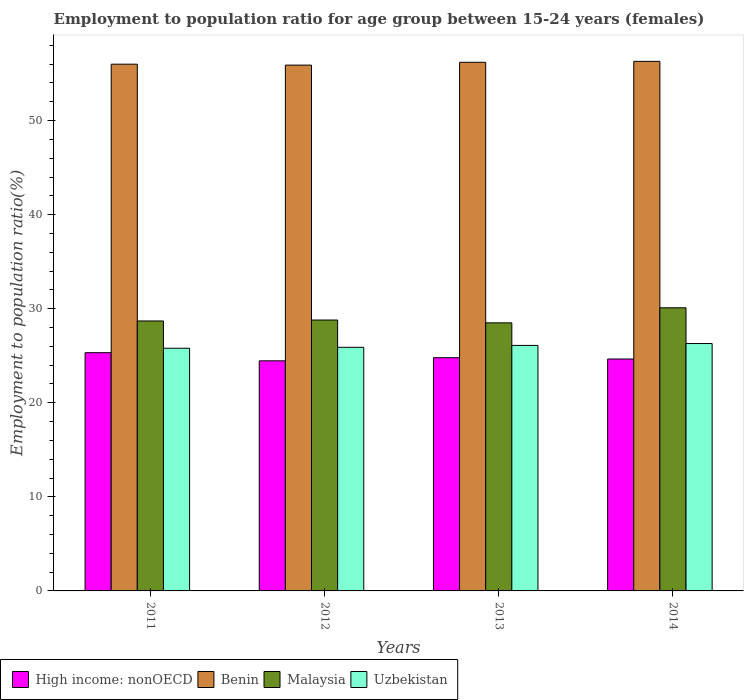How many groups of bars are there?
Your response must be concise. 4. Are the number of bars on each tick of the X-axis equal?
Offer a very short reply. Yes. How many bars are there on the 3rd tick from the right?
Your answer should be very brief. 4. In how many cases, is the number of bars for a given year not equal to the number of legend labels?
Your response must be concise. 0. What is the employment to population ratio in Benin in 2012?
Provide a succinct answer. 55.9. Across all years, what is the maximum employment to population ratio in Malaysia?
Provide a short and direct response. 30.1. Across all years, what is the minimum employment to population ratio in Benin?
Provide a short and direct response. 55.9. In which year was the employment to population ratio in Malaysia maximum?
Your answer should be very brief. 2014. In which year was the employment to population ratio in Benin minimum?
Provide a succinct answer. 2012. What is the total employment to population ratio in High income: nonOECD in the graph?
Your answer should be compact. 99.24. What is the difference between the employment to population ratio in Benin in 2013 and that in 2014?
Your response must be concise. -0.1. What is the difference between the employment to population ratio in Malaysia in 2014 and the employment to population ratio in Benin in 2013?
Provide a short and direct response. -26.1. What is the average employment to population ratio in High income: nonOECD per year?
Make the answer very short. 24.81. In the year 2013, what is the difference between the employment to population ratio in Uzbekistan and employment to population ratio in Benin?
Ensure brevity in your answer.  -30.1. What is the ratio of the employment to population ratio in High income: nonOECD in 2012 to that in 2014?
Ensure brevity in your answer.  0.99. What is the difference between the highest and the second highest employment to population ratio in Benin?
Ensure brevity in your answer.  0.1. What is the difference between the highest and the lowest employment to population ratio in Benin?
Provide a short and direct response. 0.4. In how many years, is the employment to population ratio in High income: nonOECD greater than the average employment to population ratio in High income: nonOECD taken over all years?
Your response must be concise. 1. Is it the case that in every year, the sum of the employment to population ratio in Uzbekistan and employment to population ratio in High income: nonOECD is greater than the sum of employment to population ratio in Benin and employment to population ratio in Malaysia?
Give a very brief answer. No. What does the 4th bar from the left in 2012 represents?
Keep it short and to the point. Uzbekistan. What does the 3rd bar from the right in 2013 represents?
Provide a short and direct response. Benin. Is it the case that in every year, the sum of the employment to population ratio in Benin and employment to population ratio in High income: nonOECD is greater than the employment to population ratio in Uzbekistan?
Provide a short and direct response. Yes. How many bars are there?
Ensure brevity in your answer.  16. How many years are there in the graph?
Your response must be concise. 4. Are the values on the major ticks of Y-axis written in scientific E-notation?
Give a very brief answer. No. Does the graph contain any zero values?
Provide a succinct answer. No. Does the graph contain grids?
Your answer should be compact. No. Where does the legend appear in the graph?
Your answer should be compact. Bottom left. How many legend labels are there?
Give a very brief answer. 4. What is the title of the graph?
Offer a very short reply. Employment to population ratio for age group between 15-24 years (females). Does "Benin" appear as one of the legend labels in the graph?
Keep it short and to the point. Yes. What is the label or title of the X-axis?
Give a very brief answer. Years. What is the label or title of the Y-axis?
Provide a succinct answer. Employment to population ratio(%). What is the Employment to population ratio(%) in High income: nonOECD in 2011?
Your answer should be compact. 25.33. What is the Employment to population ratio(%) in Malaysia in 2011?
Offer a terse response. 28.7. What is the Employment to population ratio(%) in Uzbekistan in 2011?
Your response must be concise. 25.8. What is the Employment to population ratio(%) of High income: nonOECD in 2012?
Your answer should be compact. 24.46. What is the Employment to population ratio(%) of Benin in 2012?
Provide a short and direct response. 55.9. What is the Employment to population ratio(%) in Malaysia in 2012?
Your answer should be very brief. 28.8. What is the Employment to population ratio(%) in Uzbekistan in 2012?
Provide a short and direct response. 25.9. What is the Employment to population ratio(%) of High income: nonOECD in 2013?
Provide a short and direct response. 24.79. What is the Employment to population ratio(%) in Benin in 2013?
Offer a very short reply. 56.2. What is the Employment to population ratio(%) in Uzbekistan in 2013?
Offer a very short reply. 26.1. What is the Employment to population ratio(%) in High income: nonOECD in 2014?
Your response must be concise. 24.66. What is the Employment to population ratio(%) in Benin in 2014?
Provide a short and direct response. 56.3. What is the Employment to population ratio(%) of Malaysia in 2014?
Give a very brief answer. 30.1. What is the Employment to population ratio(%) of Uzbekistan in 2014?
Offer a terse response. 26.3. Across all years, what is the maximum Employment to population ratio(%) of High income: nonOECD?
Offer a terse response. 25.33. Across all years, what is the maximum Employment to population ratio(%) in Benin?
Your response must be concise. 56.3. Across all years, what is the maximum Employment to population ratio(%) in Malaysia?
Offer a terse response. 30.1. Across all years, what is the maximum Employment to population ratio(%) of Uzbekistan?
Offer a very short reply. 26.3. Across all years, what is the minimum Employment to population ratio(%) of High income: nonOECD?
Your response must be concise. 24.46. Across all years, what is the minimum Employment to population ratio(%) in Benin?
Your answer should be very brief. 55.9. Across all years, what is the minimum Employment to population ratio(%) of Malaysia?
Provide a short and direct response. 28.5. Across all years, what is the minimum Employment to population ratio(%) of Uzbekistan?
Provide a succinct answer. 25.8. What is the total Employment to population ratio(%) of High income: nonOECD in the graph?
Make the answer very short. 99.24. What is the total Employment to population ratio(%) of Benin in the graph?
Your response must be concise. 224.4. What is the total Employment to population ratio(%) of Malaysia in the graph?
Keep it short and to the point. 116.1. What is the total Employment to population ratio(%) of Uzbekistan in the graph?
Provide a short and direct response. 104.1. What is the difference between the Employment to population ratio(%) of High income: nonOECD in 2011 and that in 2012?
Keep it short and to the point. 0.86. What is the difference between the Employment to population ratio(%) of Benin in 2011 and that in 2012?
Your response must be concise. 0.1. What is the difference between the Employment to population ratio(%) in Uzbekistan in 2011 and that in 2012?
Your response must be concise. -0.1. What is the difference between the Employment to population ratio(%) in High income: nonOECD in 2011 and that in 2013?
Give a very brief answer. 0.53. What is the difference between the Employment to population ratio(%) of High income: nonOECD in 2011 and that in 2014?
Offer a terse response. 0.67. What is the difference between the Employment to population ratio(%) in Malaysia in 2011 and that in 2014?
Ensure brevity in your answer.  -1.4. What is the difference between the Employment to population ratio(%) of Uzbekistan in 2011 and that in 2014?
Provide a short and direct response. -0.5. What is the difference between the Employment to population ratio(%) of High income: nonOECD in 2012 and that in 2013?
Keep it short and to the point. -0.33. What is the difference between the Employment to population ratio(%) of Benin in 2012 and that in 2013?
Your answer should be compact. -0.3. What is the difference between the Employment to population ratio(%) of Malaysia in 2012 and that in 2013?
Your response must be concise. 0.3. What is the difference between the Employment to population ratio(%) of Uzbekistan in 2012 and that in 2013?
Keep it short and to the point. -0.2. What is the difference between the Employment to population ratio(%) in High income: nonOECD in 2012 and that in 2014?
Give a very brief answer. -0.19. What is the difference between the Employment to population ratio(%) of Benin in 2012 and that in 2014?
Offer a terse response. -0.4. What is the difference between the Employment to population ratio(%) of Malaysia in 2012 and that in 2014?
Your response must be concise. -1.3. What is the difference between the Employment to population ratio(%) in High income: nonOECD in 2013 and that in 2014?
Offer a very short reply. 0.14. What is the difference between the Employment to population ratio(%) in Benin in 2013 and that in 2014?
Provide a succinct answer. -0.1. What is the difference between the Employment to population ratio(%) of Malaysia in 2013 and that in 2014?
Your answer should be compact. -1.6. What is the difference between the Employment to population ratio(%) in High income: nonOECD in 2011 and the Employment to population ratio(%) in Benin in 2012?
Give a very brief answer. -30.57. What is the difference between the Employment to population ratio(%) of High income: nonOECD in 2011 and the Employment to population ratio(%) of Malaysia in 2012?
Provide a succinct answer. -3.47. What is the difference between the Employment to population ratio(%) in High income: nonOECD in 2011 and the Employment to population ratio(%) in Uzbekistan in 2012?
Ensure brevity in your answer.  -0.57. What is the difference between the Employment to population ratio(%) in Benin in 2011 and the Employment to population ratio(%) in Malaysia in 2012?
Your answer should be compact. 27.2. What is the difference between the Employment to population ratio(%) in Benin in 2011 and the Employment to population ratio(%) in Uzbekistan in 2012?
Keep it short and to the point. 30.1. What is the difference between the Employment to population ratio(%) in Malaysia in 2011 and the Employment to population ratio(%) in Uzbekistan in 2012?
Offer a very short reply. 2.8. What is the difference between the Employment to population ratio(%) in High income: nonOECD in 2011 and the Employment to population ratio(%) in Benin in 2013?
Offer a very short reply. -30.87. What is the difference between the Employment to population ratio(%) in High income: nonOECD in 2011 and the Employment to population ratio(%) in Malaysia in 2013?
Keep it short and to the point. -3.17. What is the difference between the Employment to population ratio(%) of High income: nonOECD in 2011 and the Employment to population ratio(%) of Uzbekistan in 2013?
Keep it short and to the point. -0.77. What is the difference between the Employment to population ratio(%) in Benin in 2011 and the Employment to population ratio(%) in Malaysia in 2013?
Provide a succinct answer. 27.5. What is the difference between the Employment to population ratio(%) in Benin in 2011 and the Employment to population ratio(%) in Uzbekistan in 2013?
Give a very brief answer. 29.9. What is the difference between the Employment to population ratio(%) in Malaysia in 2011 and the Employment to population ratio(%) in Uzbekistan in 2013?
Your answer should be very brief. 2.6. What is the difference between the Employment to population ratio(%) in High income: nonOECD in 2011 and the Employment to population ratio(%) in Benin in 2014?
Offer a very short reply. -30.97. What is the difference between the Employment to population ratio(%) in High income: nonOECD in 2011 and the Employment to population ratio(%) in Malaysia in 2014?
Provide a short and direct response. -4.77. What is the difference between the Employment to population ratio(%) in High income: nonOECD in 2011 and the Employment to population ratio(%) in Uzbekistan in 2014?
Offer a very short reply. -0.97. What is the difference between the Employment to population ratio(%) in Benin in 2011 and the Employment to population ratio(%) in Malaysia in 2014?
Offer a terse response. 25.9. What is the difference between the Employment to population ratio(%) in Benin in 2011 and the Employment to population ratio(%) in Uzbekistan in 2014?
Offer a very short reply. 29.7. What is the difference between the Employment to population ratio(%) in Malaysia in 2011 and the Employment to population ratio(%) in Uzbekistan in 2014?
Offer a terse response. 2.4. What is the difference between the Employment to population ratio(%) in High income: nonOECD in 2012 and the Employment to population ratio(%) in Benin in 2013?
Your response must be concise. -31.74. What is the difference between the Employment to population ratio(%) of High income: nonOECD in 2012 and the Employment to population ratio(%) of Malaysia in 2013?
Offer a terse response. -4.04. What is the difference between the Employment to population ratio(%) of High income: nonOECD in 2012 and the Employment to population ratio(%) of Uzbekistan in 2013?
Your answer should be compact. -1.64. What is the difference between the Employment to population ratio(%) of Benin in 2012 and the Employment to population ratio(%) of Malaysia in 2013?
Your answer should be compact. 27.4. What is the difference between the Employment to population ratio(%) in Benin in 2012 and the Employment to population ratio(%) in Uzbekistan in 2013?
Give a very brief answer. 29.8. What is the difference between the Employment to population ratio(%) of Malaysia in 2012 and the Employment to population ratio(%) of Uzbekistan in 2013?
Provide a succinct answer. 2.7. What is the difference between the Employment to population ratio(%) in High income: nonOECD in 2012 and the Employment to population ratio(%) in Benin in 2014?
Ensure brevity in your answer.  -31.84. What is the difference between the Employment to population ratio(%) of High income: nonOECD in 2012 and the Employment to population ratio(%) of Malaysia in 2014?
Ensure brevity in your answer.  -5.64. What is the difference between the Employment to population ratio(%) of High income: nonOECD in 2012 and the Employment to population ratio(%) of Uzbekistan in 2014?
Ensure brevity in your answer.  -1.84. What is the difference between the Employment to population ratio(%) of Benin in 2012 and the Employment to population ratio(%) of Malaysia in 2014?
Provide a short and direct response. 25.8. What is the difference between the Employment to population ratio(%) of Benin in 2012 and the Employment to population ratio(%) of Uzbekistan in 2014?
Ensure brevity in your answer.  29.6. What is the difference between the Employment to population ratio(%) of Malaysia in 2012 and the Employment to population ratio(%) of Uzbekistan in 2014?
Offer a very short reply. 2.5. What is the difference between the Employment to population ratio(%) in High income: nonOECD in 2013 and the Employment to population ratio(%) in Benin in 2014?
Offer a very short reply. -31.51. What is the difference between the Employment to population ratio(%) of High income: nonOECD in 2013 and the Employment to population ratio(%) of Malaysia in 2014?
Give a very brief answer. -5.31. What is the difference between the Employment to population ratio(%) in High income: nonOECD in 2013 and the Employment to population ratio(%) in Uzbekistan in 2014?
Ensure brevity in your answer.  -1.51. What is the difference between the Employment to population ratio(%) in Benin in 2013 and the Employment to population ratio(%) in Malaysia in 2014?
Make the answer very short. 26.1. What is the difference between the Employment to population ratio(%) in Benin in 2013 and the Employment to population ratio(%) in Uzbekistan in 2014?
Make the answer very short. 29.9. What is the average Employment to population ratio(%) of High income: nonOECD per year?
Ensure brevity in your answer.  24.81. What is the average Employment to population ratio(%) in Benin per year?
Ensure brevity in your answer.  56.1. What is the average Employment to population ratio(%) of Malaysia per year?
Provide a succinct answer. 29.02. What is the average Employment to population ratio(%) of Uzbekistan per year?
Your answer should be very brief. 26.02. In the year 2011, what is the difference between the Employment to population ratio(%) of High income: nonOECD and Employment to population ratio(%) of Benin?
Provide a short and direct response. -30.67. In the year 2011, what is the difference between the Employment to population ratio(%) in High income: nonOECD and Employment to population ratio(%) in Malaysia?
Your response must be concise. -3.37. In the year 2011, what is the difference between the Employment to population ratio(%) of High income: nonOECD and Employment to population ratio(%) of Uzbekistan?
Give a very brief answer. -0.47. In the year 2011, what is the difference between the Employment to population ratio(%) in Benin and Employment to population ratio(%) in Malaysia?
Give a very brief answer. 27.3. In the year 2011, what is the difference between the Employment to population ratio(%) in Benin and Employment to population ratio(%) in Uzbekistan?
Ensure brevity in your answer.  30.2. In the year 2012, what is the difference between the Employment to population ratio(%) in High income: nonOECD and Employment to population ratio(%) in Benin?
Provide a short and direct response. -31.44. In the year 2012, what is the difference between the Employment to population ratio(%) of High income: nonOECD and Employment to population ratio(%) of Malaysia?
Your response must be concise. -4.34. In the year 2012, what is the difference between the Employment to population ratio(%) of High income: nonOECD and Employment to population ratio(%) of Uzbekistan?
Offer a very short reply. -1.44. In the year 2012, what is the difference between the Employment to population ratio(%) in Benin and Employment to population ratio(%) in Malaysia?
Keep it short and to the point. 27.1. In the year 2012, what is the difference between the Employment to population ratio(%) of Benin and Employment to population ratio(%) of Uzbekistan?
Your answer should be very brief. 30. In the year 2013, what is the difference between the Employment to population ratio(%) in High income: nonOECD and Employment to population ratio(%) in Benin?
Provide a short and direct response. -31.41. In the year 2013, what is the difference between the Employment to population ratio(%) in High income: nonOECD and Employment to population ratio(%) in Malaysia?
Keep it short and to the point. -3.71. In the year 2013, what is the difference between the Employment to population ratio(%) in High income: nonOECD and Employment to population ratio(%) in Uzbekistan?
Offer a terse response. -1.31. In the year 2013, what is the difference between the Employment to population ratio(%) in Benin and Employment to population ratio(%) in Malaysia?
Offer a terse response. 27.7. In the year 2013, what is the difference between the Employment to population ratio(%) in Benin and Employment to population ratio(%) in Uzbekistan?
Provide a succinct answer. 30.1. In the year 2013, what is the difference between the Employment to population ratio(%) in Malaysia and Employment to population ratio(%) in Uzbekistan?
Keep it short and to the point. 2.4. In the year 2014, what is the difference between the Employment to population ratio(%) in High income: nonOECD and Employment to population ratio(%) in Benin?
Provide a short and direct response. -31.64. In the year 2014, what is the difference between the Employment to population ratio(%) in High income: nonOECD and Employment to population ratio(%) in Malaysia?
Your answer should be very brief. -5.44. In the year 2014, what is the difference between the Employment to population ratio(%) in High income: nonOECD and Employment to population ratio(%) in Uzbekistan?
Give a very brief answer. -1.64. In the year 2014, what is the difference between the Employment to population ratio(%) in Benin and Employment to population ratio(%) in Malaysia?
Offer a terse response. 26.2. In the year 2014, what is the difference between the Employment to population ratio(%) of Benin and Employment to population ratio(%) of Uzbekistan?
Your answer should be compact. 30. What is the ratio of the Employment to population ratio(%) of High income: nonOECD in 2011 to that in 2012?
Your answer should be compact. 1.04. What is the ratio of the Employment to population ratio(%) in Benin in 2011 to that in 2012?
Your answer should be very brief. 1. What is the ratio of the Employment to population ratio(%) of High income: nonOECD in 2011 to that in 2013?
Offer a very short reply. 1.02. What is the ratio of the Employment to population ratio(%) of High income: nonOECD in 2011 to that in 2014?
Offer a terse response. 1.03. What is the ratio of the Employment to population ratio(%) in Benin in 2011 to that in 2014?
Make the answer very short. 0.99. What is the ratio of the Employment to population ratio(%) of Malaysia in 2011 to that in 2014?
Your answer should be very brief. 0.95. What is the ratio of the Employment to population ratio(%) of Uzbekistan in 2011 to that in 2014?
Your answer should be very brief. 0.98. What is the ratio of the Employment to population ratio(%) of High income: nonOECD in 2012 to that in 2013?
Ensure brevity in your answer.  0.99. What is the ratio of the Employment to population ratio(%) in Benin in 2012 to that in 2013?
Offer a very short reply. 0.99. What is the ratio of the Employment to population ratio(%) of Malaysia in 2012 to that in 2013?
Provide a short and direct response. 1.01. What is the ratio of the Employment to population ratio(%) of Benin in 2012 to that in 2014?
Offer a very short reply. 0.99. What is the ratio of the Employment to population ratio(%) of Malaysia in 2012 to that in 2014?
Provide a succinct answer. 0.96. What is the ratio of the Employment to population ratio(%) of Uzbekistan in 2012 to that in 2014?
Your answer should be very brief. 0.98. What is the ratio of the Employment to population ratio(%) in High income: nonOECD in 2013 to that in 2014?
Offer a very short reply. 1.01. What is the ratio of the Employment to population ratio(%) in Malaysia in 2013 to that in 2014?
Offer a very short reply. 0.95. What is the ratio of the Employment to population ratio(%) of Uzbekistan in 2013 to that in 2014?
Your response must be concise. 0.99. What is the difference between the highest and the second highest Employment to population ratio(%) of High income: nonOECD?
Offer a terse response. 0.53. What is the difference between the highest and the second highest Employment to population ratio(%) of Uzbekistan?
Give a very brief answer. 0.2. What is the difference between the highest and the lowest Employment to population ratio(%) in High income: nonOECD?
Offer a very short reply. 0.86. What is the difference between the highest and the lowest Employment to population ratio(%) of Benin?
Offer a terse response. 0.4. What is the difference between the highest and the lowest Employment to population ratio(%) of Malaysia?
Provide a short and direct response. 1.6. 